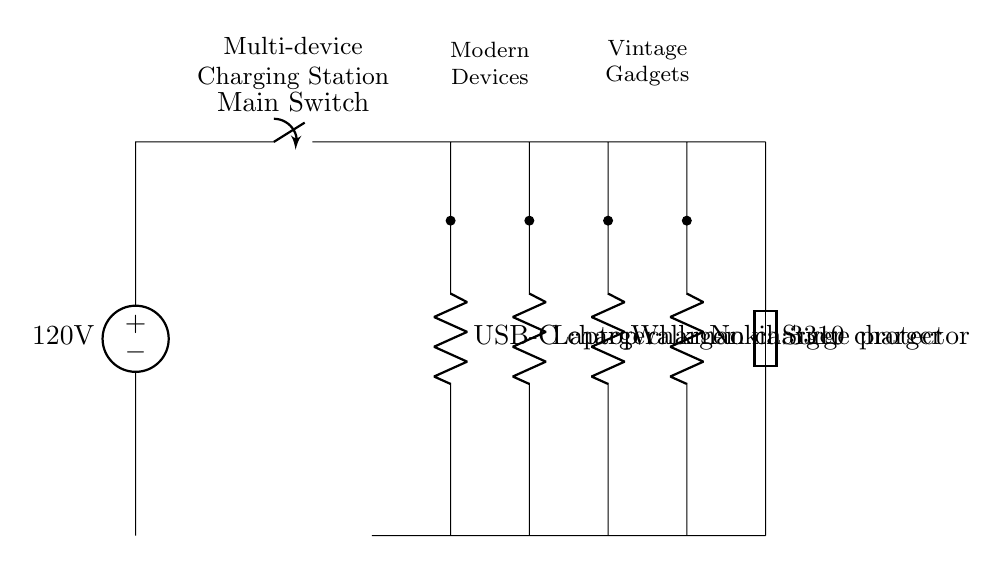What is the main voltage source of the circuit? The main voltage source is specified as 120 volts. This is indicated by the label on the voltage source symbol at the beginning of the circuit.
Answer: 120 volts What type of charging device is used for modern devices? The charging device for modern devices is labeled as USB-C charger, indicated by the resistor symbol in the circuit.
Answer: USB-C charger How many vintage device chargers are represented in the circuit? There are two vintage device chargers represented: one for the Walkman and one for the Nokia 3310. This information can be seen in the respective components labeled next to the short connections.
Answer: Two What is the purpose of the fuse in this circuit? The fuse serves as a surge protector, helping to prevent damage to the devices by breaking the circuit when an overload occurs. Its labeling as “Surge protector” indicates this function directly in the diagram.
Answer: Surge protector Why is there a switch in this circuit? The switch is included to allow users to easily turn the power on or off for the entire charging station, providing a convenient control over the power supply to all connected devices. Its placement at the beginning of the circuit allows for rapid access.
Answer: To control power supply Which devices are available for modern gadgets in this setup? The charging devices available for modern gadgets in this setup include a USB-C charger and a Laptop charger, which are both connected directly to the power strip section of the diagram. The labels next to these components provide their identities clearly.
Answer: USB-C charger, Laptop charger 